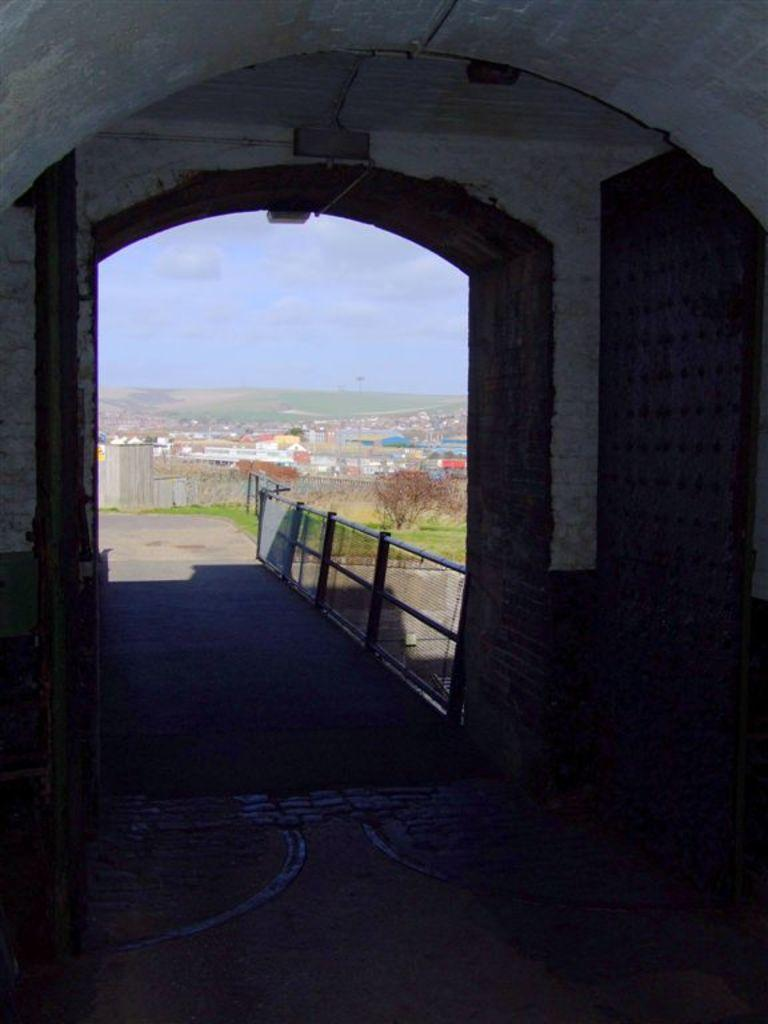What structure is the main subject of the image? There is a bridge in the image. What feature can be seen on the bridge? The bridge has railing. What type of vegetation is present in the image? There is grass and trees in the image. What can be seen in the background of the image? There are buildings, the ground, and the sky visible in the background of the image. How many girls are participating in the rhythmic voyage in the image? There are no girls or any indication of a voyage in the image; it features a bridge with railing, grass, trees, and a background with buildings, the ground, and the sky. 